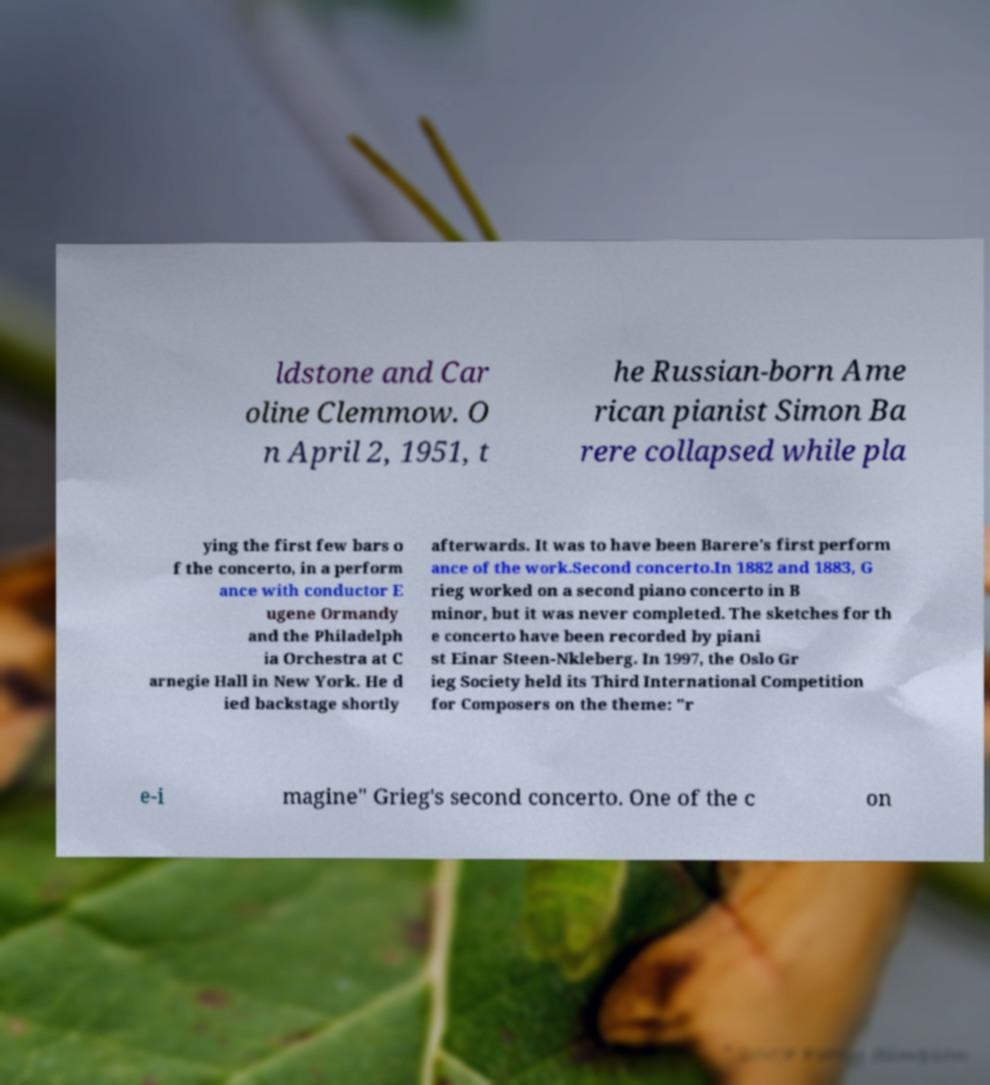Please identify and transcribe the text found in this image. ldstone and Car oline Clemmow. O n April 2, 1951, t he Russian-born Ame rican pianist Simon Ba rere collapsed while pla ying the first few bars o f the concerto, in a perform ance with conductor E ugene Ormandy and the Philadelph ia Orchestra at C arnegie Hall in New York. He d ied backstage shortly afterwards. It was to have been Barere's first perform ance of the work.Second concerto.In 1882 and 1883, G rieg worked on a second piano concerto in B minor, but it was never completed. The sketches for th e concerto have been recorded by piani st Einar Steen-Nkleberg. In 1997, the Oslo Gr ieg Society held its Third International Competition for Composers on the theme: "r e-i magine" Grieg's second concerto. One of the c on 